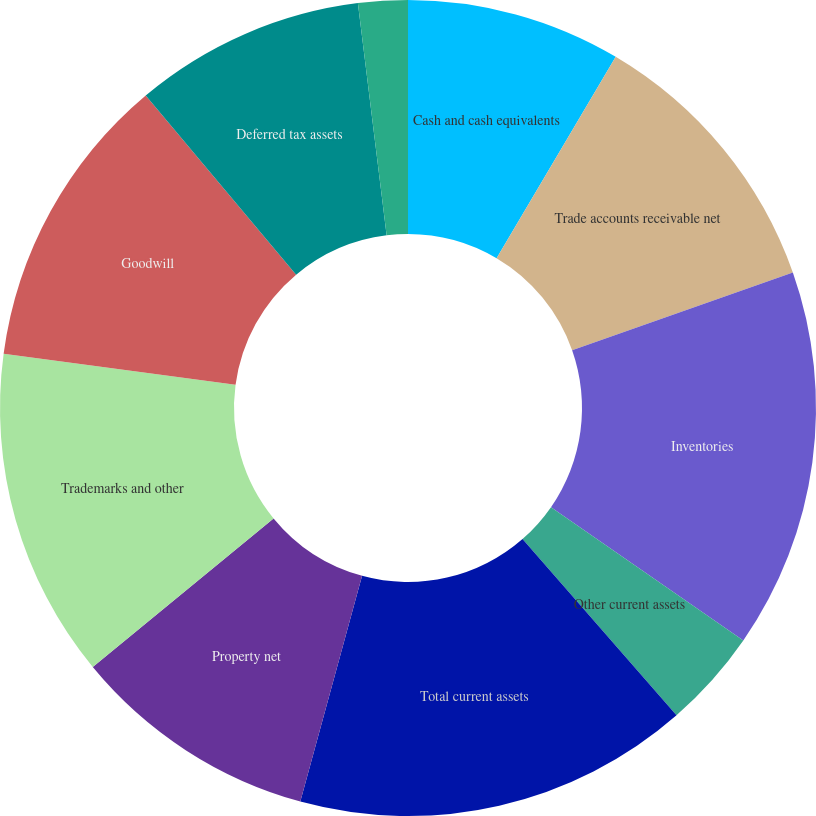Convert chart to OTSL. <chart><loc_0><loc_0><loc_500><loc_500><pie_chart><fcel>Cash and cash equivalents<fcel>Trade accounts receivable net<fcel>Inventories<fcel>Other current assets<fcel>Total current assets<fcel>Property net<fcel>Trademarks and other<fcel>Goodwill<fcel>Deferred tax assets<fcel>Other noncurrent assets<nl><fcel>8.5%<fcel>11.11%<fcel>15.03%<fcel>3.92%<fcel>15.68%<fcel>9.8%<fcel>13.07%<fcel>11.76%<fcel>9.15%<fcel>1.96%<nl></chart> 